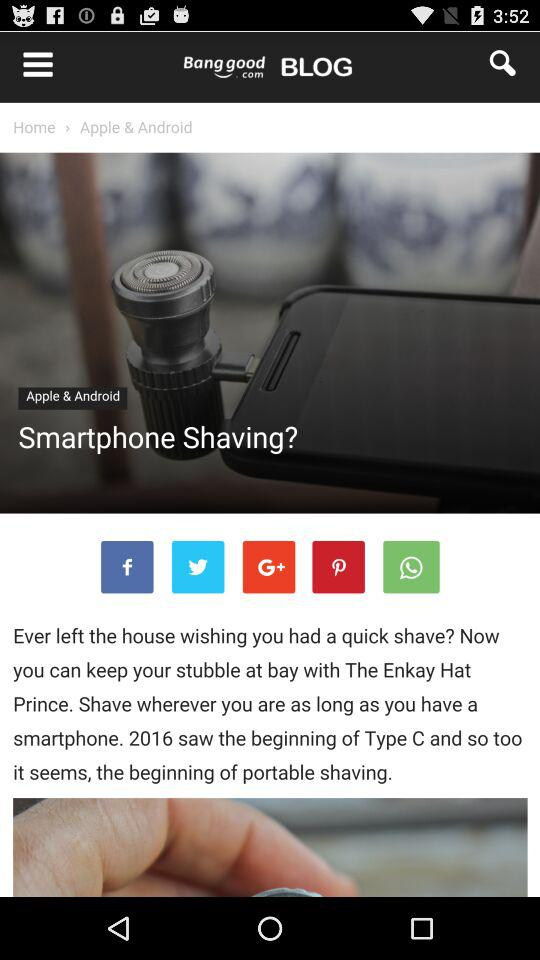What are the items in the hot search? The items are: "Led lights", "Rc quadcopter", "Nail Art", and "led bulb". 